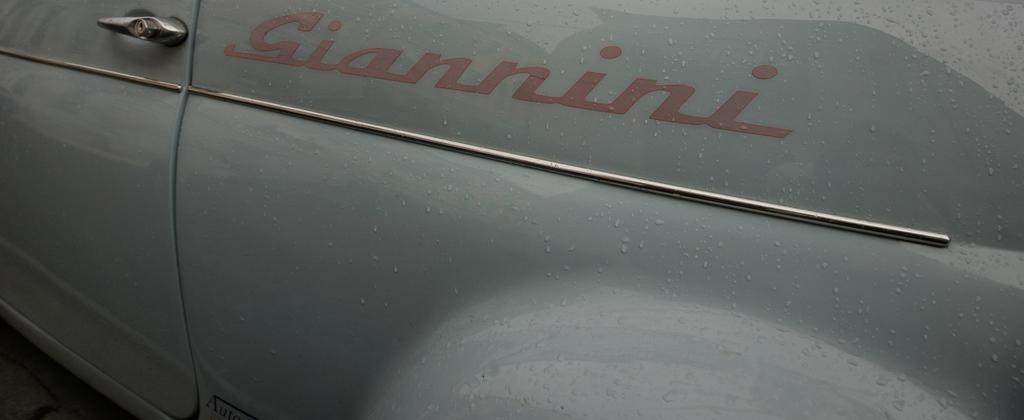What type of vehicle is in the image? The specific type of vehicle is not mentioned, but there is a vehicle present in the image. What feature of the vehicle is visible in the image? There is a door with a handle visible in the image. Are there any words or letters visible in the image? Yes, there is some text visible in the image. What can be seen on the surface of the vehicle? Water droplets are present in the image. How many times has the secretary folded the linen in the image? There is no secretary or linen present in the image. 